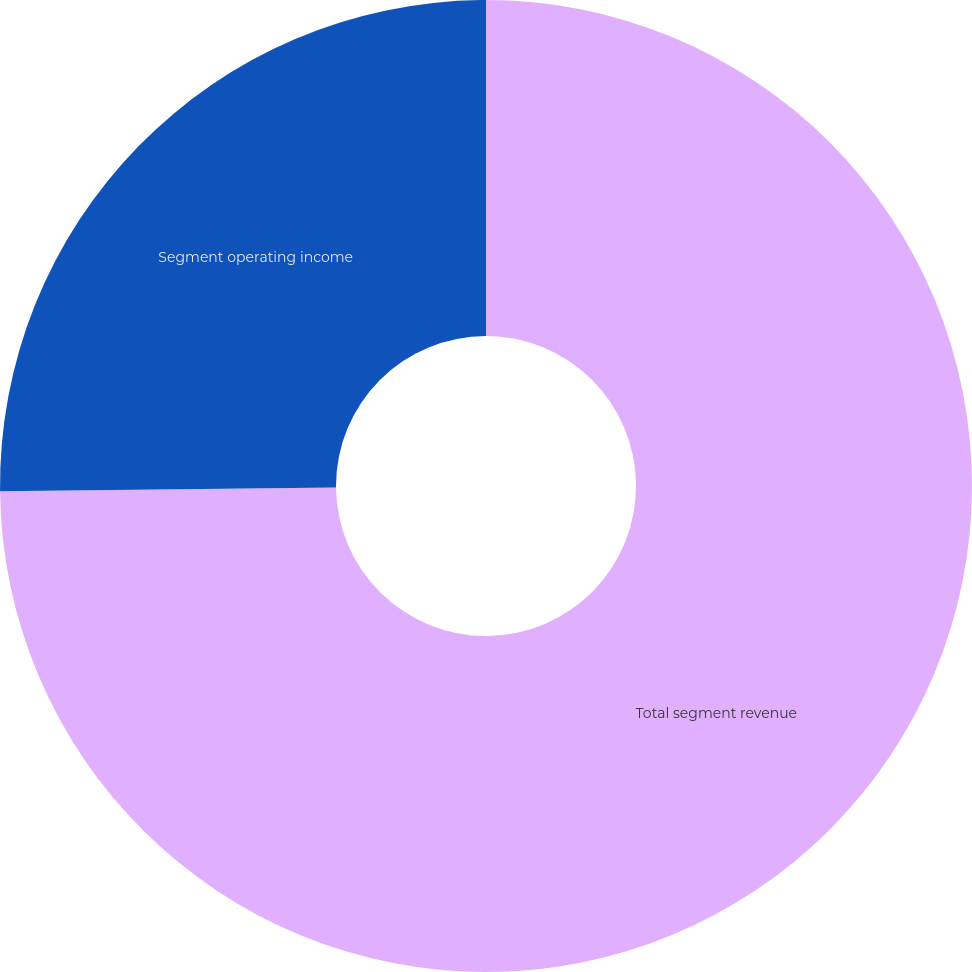Convert chart to OTSL. <chart><loc_0><loc_0><loc_500><loc_500><pie_chart><fcel>Total segment revenue<fcel>Segment operating income<nl><fcel>74.83%<fcel>25.17%<nl></chart> 